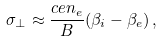<formula> <loc_0><loc_0><loc_500><loc_500>\sigma _ { \perp } \approx \frac { c e n _ { e } } { B } ( \beta _ { i } - \beta _ { e } ) \, ,</formula> 